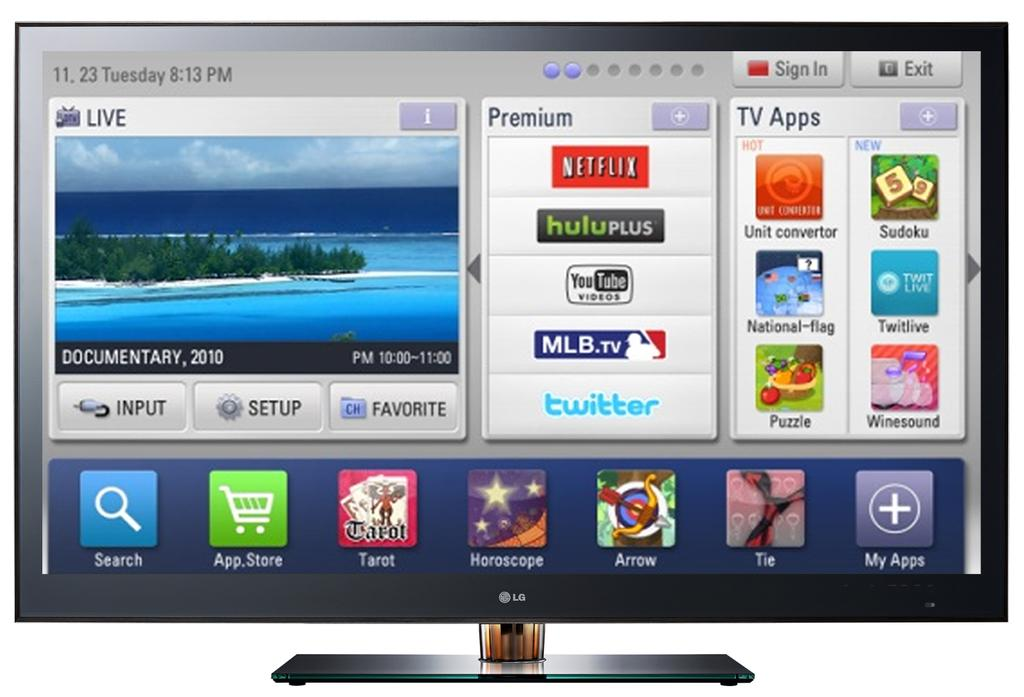<image>
Summarize the visual content of the image. TV Screen with many apps that says 11.23 Tuesday 8:13 PM. 